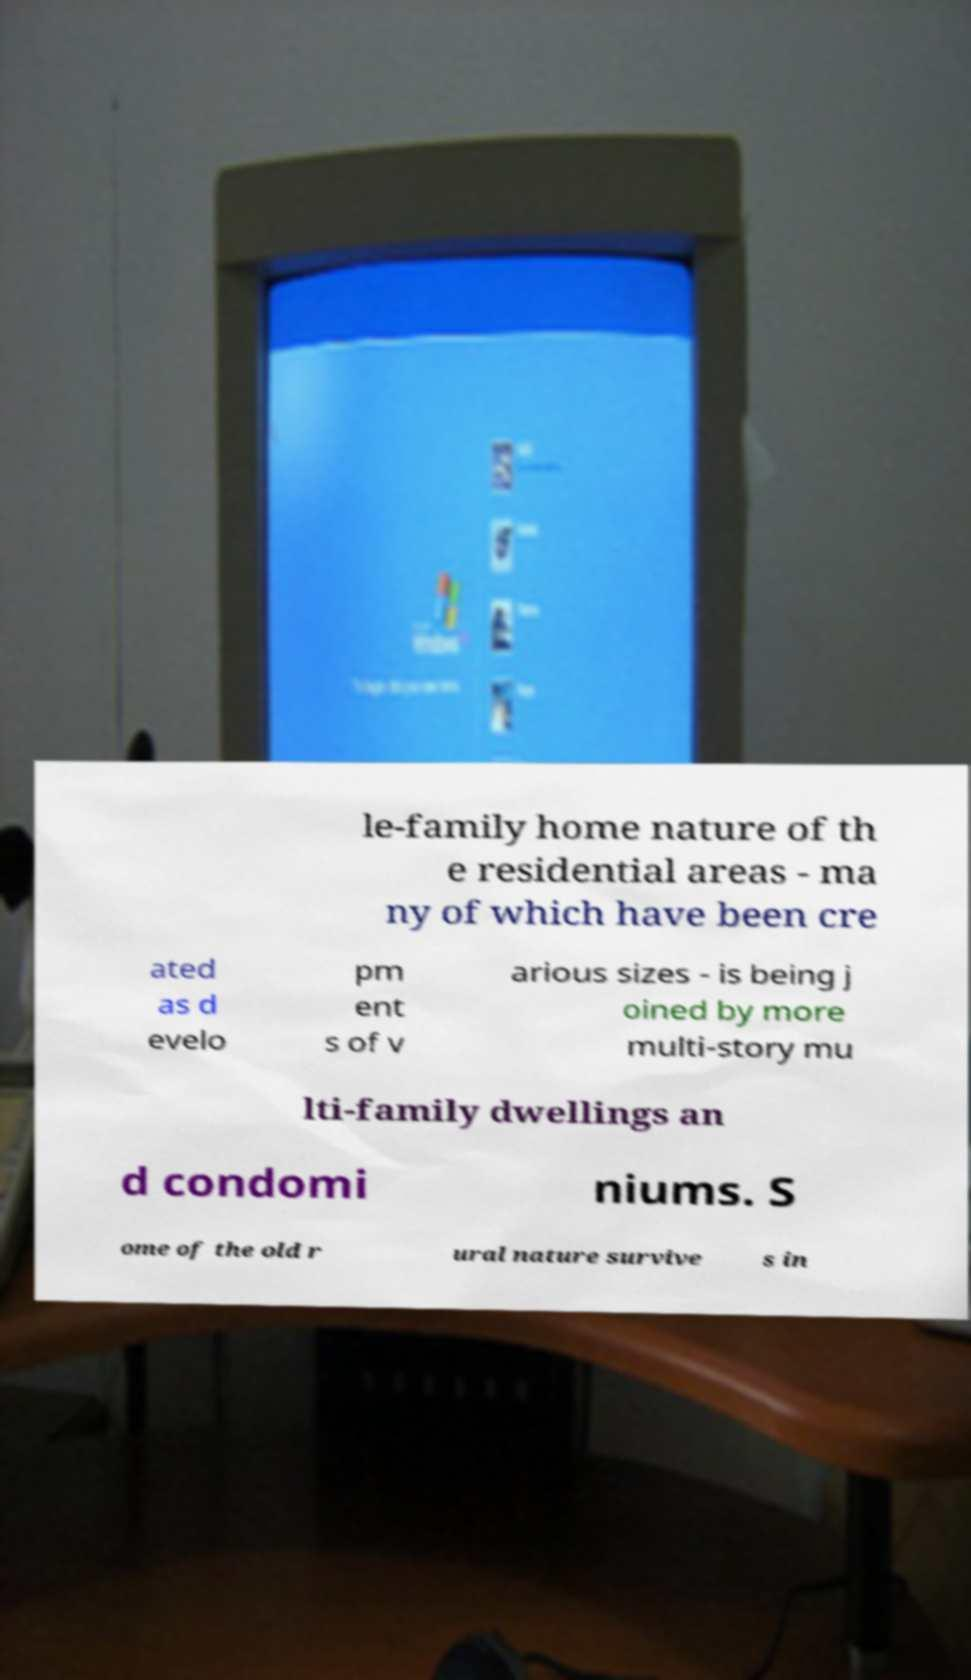I need the written content from this picture converted into text. Can you do that? le-family home nature of th e residential areas - ma ny of which have been cre ated as d evelo pm ent s of v arious sizes - is being j oined by more multi-story mu lti-family dwellings an d condomi niums. S ome of the old r ural nature survive s in 